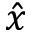<formula> <loc_0><loc_0><loc_500><loc_500>\hat { x }</formula> 